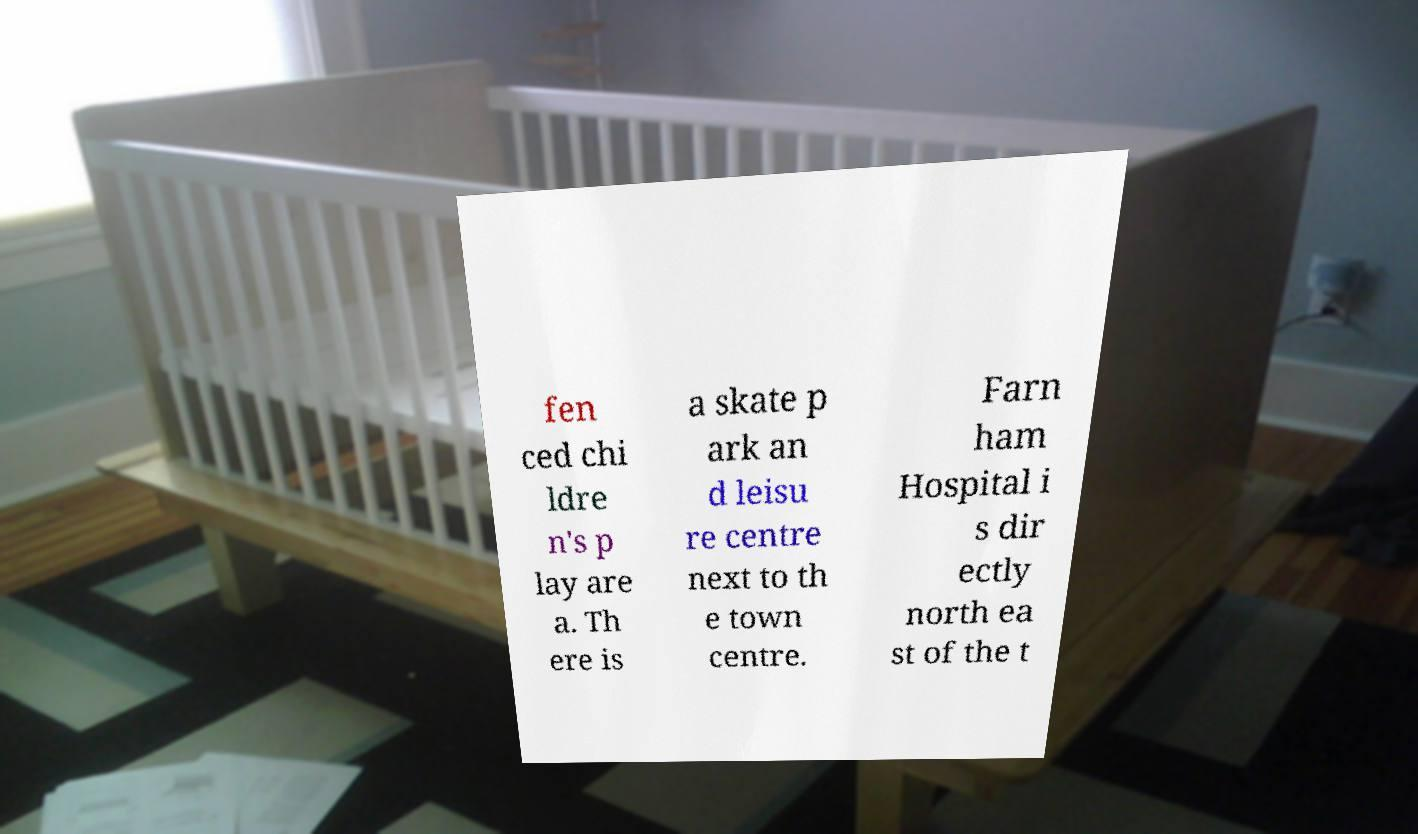What messages or text are displayed in this image? I need them in a readable, typed format. fen ced chi ldre n's p lay are a. Th ere is a skate p ark an d leisu re centre next to th e town centre. Farn ham Hospital i s dir ectly north ea st of the t 